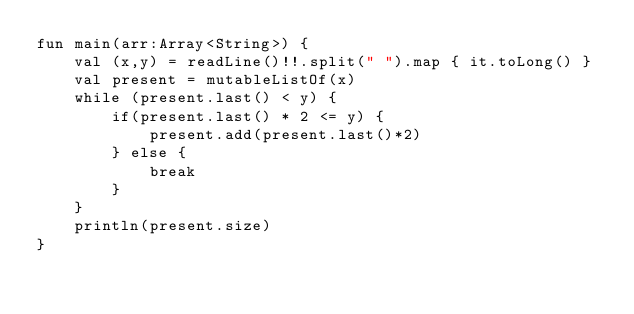<code> <loc_0><loc_0><loc_500><loc_500><_Kotlin_>fun main(arr:Array<String>) {
    val (x,y) = readLine()!!.split(" ").map { it.toLong() }
    val present = mutableListOf(x)
    while (present.last() < y) {
        if(present.last() * 2 <= y) {
            present.add(present.last()*2)
        } else {
            break
        }
    }
    println(present.size)
}
</code> 